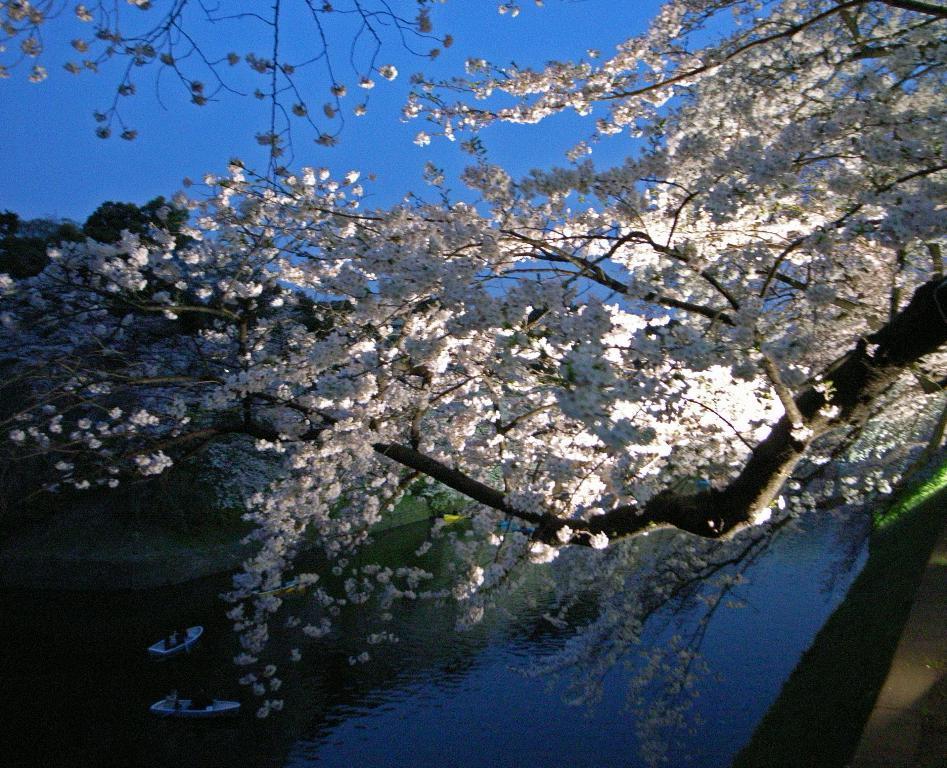Describe this image in one or two sentences. This picture is taken from outside of the city. In this image, we can see trees with plants. In the background, we can see the sky, which is in blue color. In the right corner, we can also see black color. 